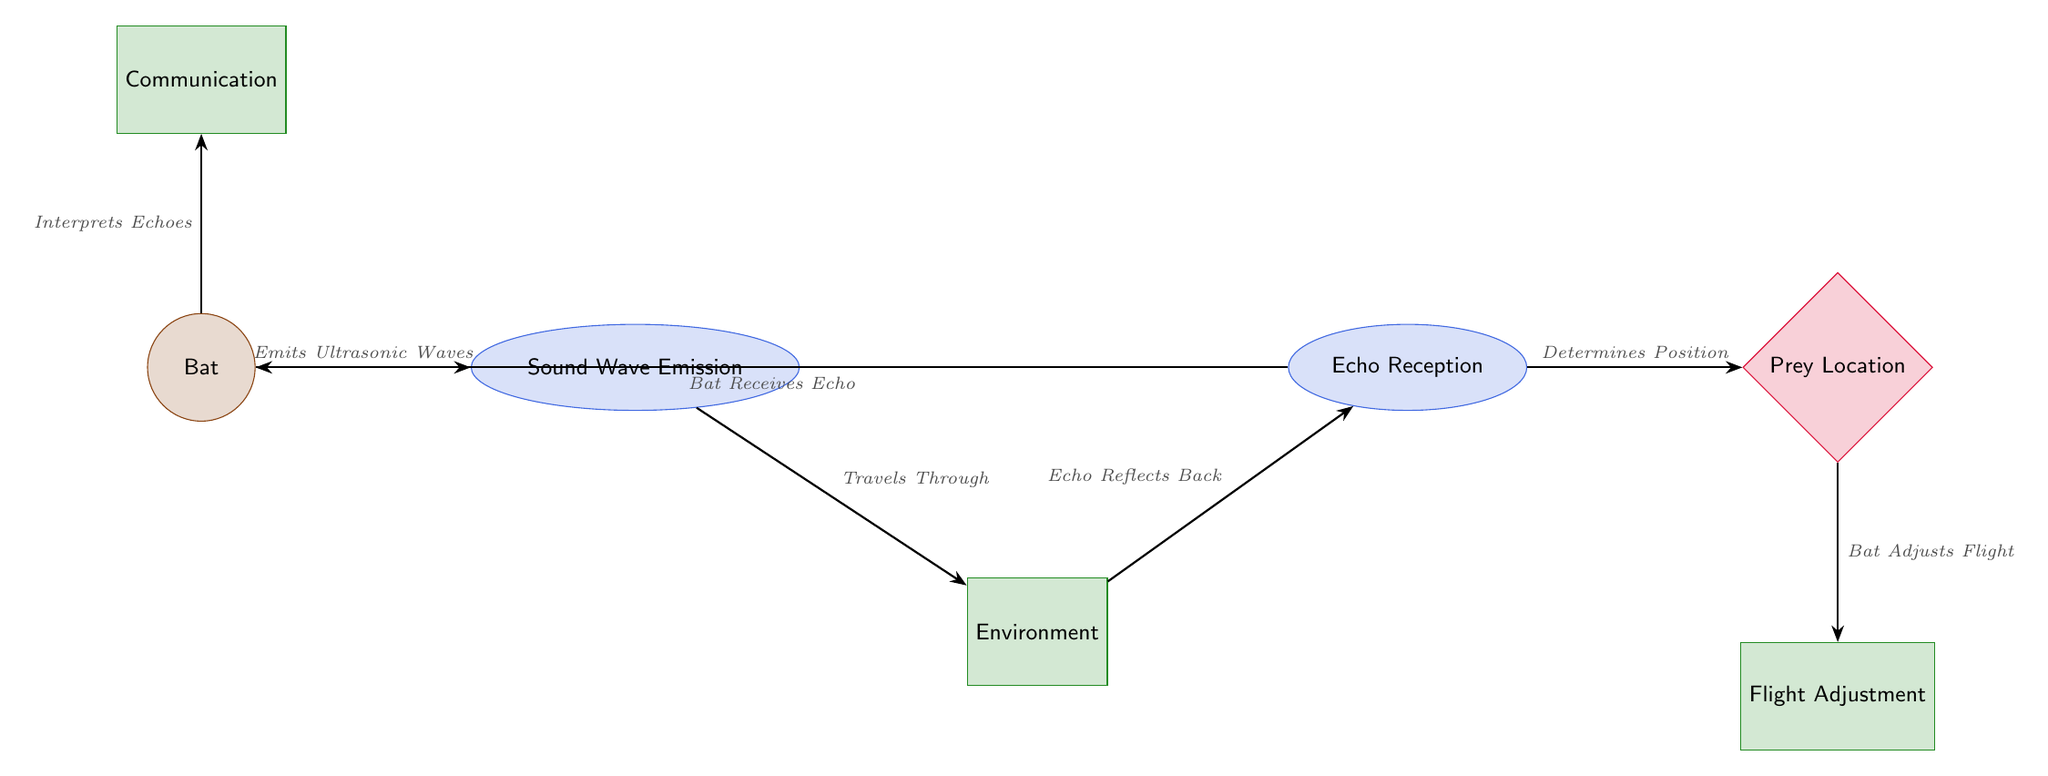What does the bat do? The bat emits ultrasonic waves, which is the primary action displayed in the diagram.
Answer: Emits Ultrasonic Waves What is the first process shown in the diagram? The diagram begins with the bat, which emits sound waves as its first action.
Answer: Sound Wave Emission How many entities are represented in this diagram? There are a total of six entities represented: Bat, Sound Wave Emission, Environment, Echo Reception, Prey Location, and Flight Adjustment.
Answer: Six What does the bat receive? The bat receives echoes that reflect off the environment, which is demonstrated as the second-to-last action in the process.
Answer: Echo Which part of the diagram represents the prey? The prey is depicted as a diamond-shaped node labeled "Prey Location," indicating where the bat determines the prey's position.
Answer: Prey Location What is the role of the environment in echolocation? The environment acts as a medium through which sound waves travel and reflect back, facilitating the bat's echolocation ability.
Answer: Travels Through What happens to the bat's flight based on the echo received? The bat adjusts its flight according to the determined position of prey based on the echoes received.
Answer: Bat Adjusts Flight What does the bat interpret? The bat interprets the echoes, which is crucial for understanding the location and distance of objects in its environment.
Answer: Echoes How does the bat communicate? The bat communicates with others during the echolocation process, which is shown as a separate edge leading to the bat.
Answer: Communication 